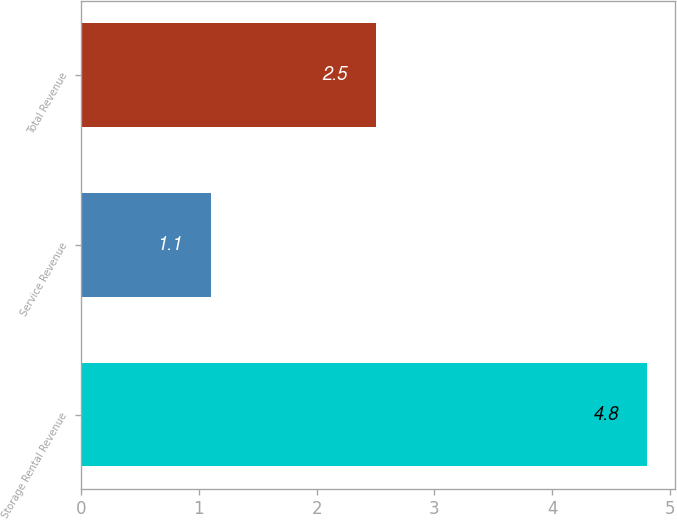Convert chart to OTSL. <chart><loc_0><loc_0><loc_500><loc_500><bar_chart><fcel>Storage Rental Revenue<fcel>Service Revenue<fcel>Total Revenue<nl><fcel>4.8<fcel>1.1<fcel>2.5<nl></chart> 